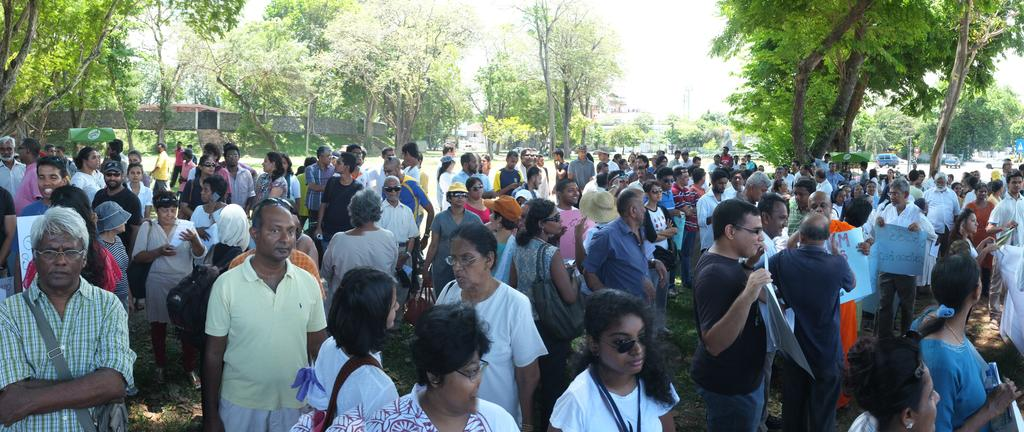What is the main subject in the foreground of the image? There is a crowd in the foreground of the image. What is the crowd standing on? The crowd is standing on the ground. What can be seen in the background of the image? There are trees and the sky visible in the background of the image. How many toes are visible on the people in the crowd? It is impossible to determine the number of toes visible on the people in the crowd from the image alone, as feet are not clearly visible. 